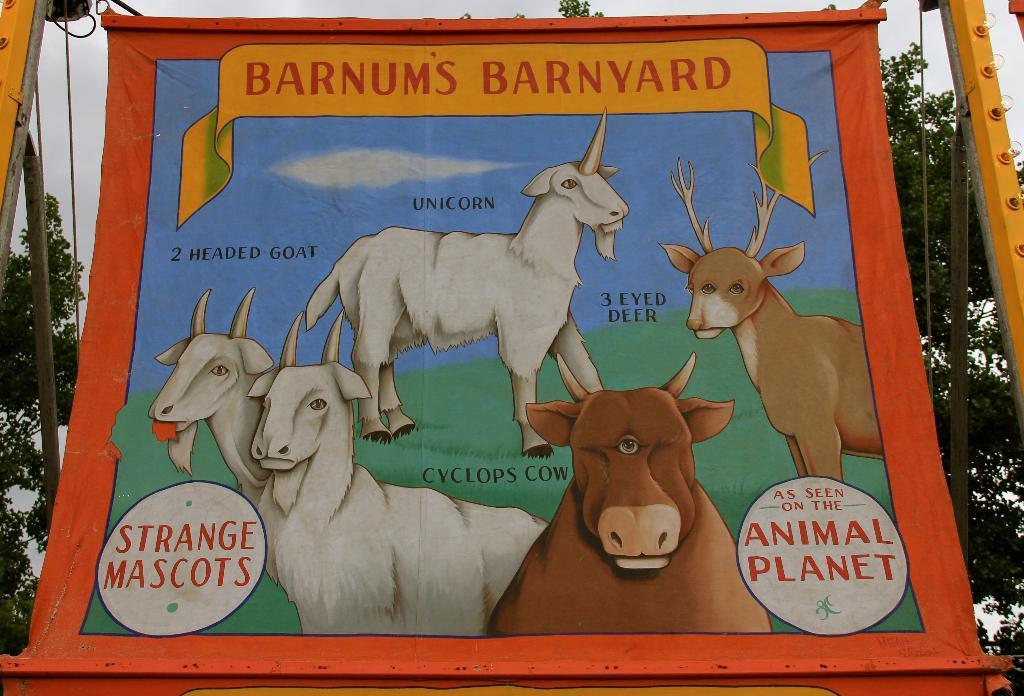Describe this image in one or two sentences. There is a poster in the center of the image where, we can see animals on it and there are trees, wires and sky in the background area. 